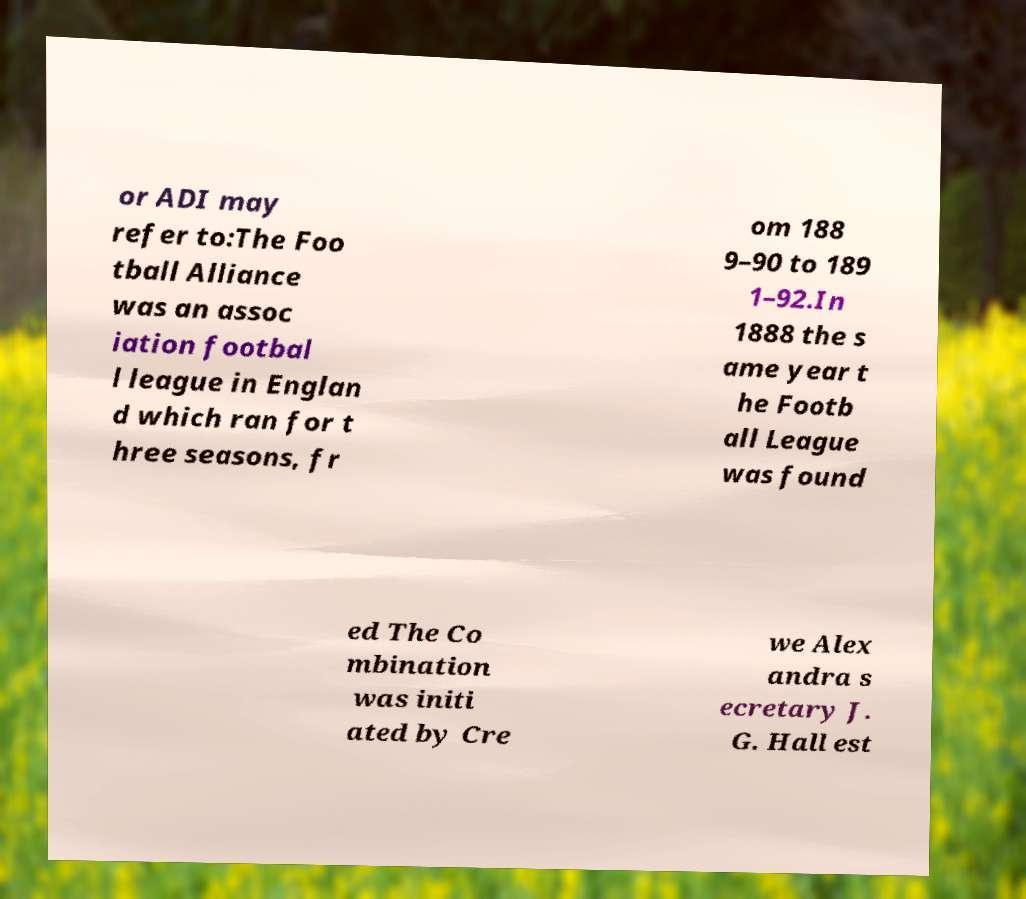Can you accurately transcribe the text from the provided image for me? or ADI may refer to:The Foo tball Alliance was an assoc iation footbal l league in Englan d which ran for t hree seasons, fr om 188 9–90 to 189 1–92.In 1888 the s ame year t he Footb all League was found ed The Co mbination was initi ated by Cre we Alex andra s ecretary J. G. Hall est 